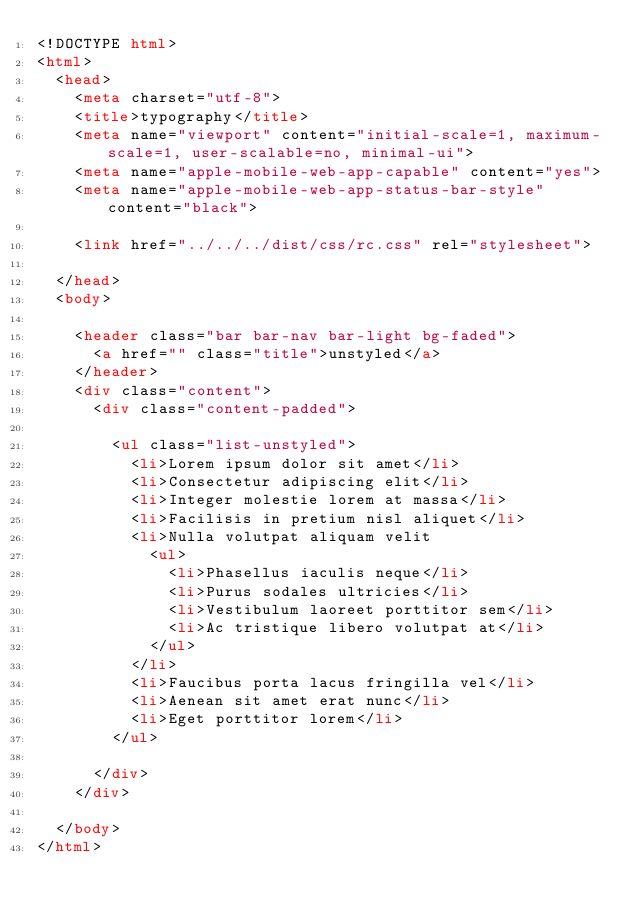<code> <loc_0><loc_0><loc_500><loc_500><_HTML_><!DOCTYPE html>
<html>
	<head>
		<meta charset="utf-8">
		<title>typography</title>
		<meta name="viewport" content="initial-scale=1, maximum-scale=1, user-scalable=no, minimal-ui">
		<meta name="apple-mobile-web-app-capable" content="yes">
		<meta name="apple-mobile-web-app-status-bar-style" content="black">

		<link href="../../../dist/css/rc.css" rel="stylesheet">

	</head>
	<body>

		<header class="bar bar-nav bar-light bg-faded">
		  <a href="" class="title">unstyled</a>
		</header>
		<div class="content">
			<div class="content-padded">

				<ul class="list-unstyled">
				  <li>Lorem ipsum dolor sit amet</li>
				  <li>Consectetur adipiscing elit</li>
				  <li>Integer molestie lorem at massa</li>
				  <li>Facilisis in pretium nisl aliquet</li>
				  <li>Nulla volutpat aliquam velit
				    <ul>
				      <li>Phasellus iaculis neque</li>
				      <li>Purus sodales ultricies</li>
				      <li>Vestibulum laoreet porttitor sem</li>
				      <li>Ac tristique libero volutpat at</li>
				    </ul>
				  </li>
				  <li>Faucibus porta lacus fringilla vel</li>
				  <li>Aenean sit amet erat nunc</li>
				  <li>Eget porttitor lorem</li>
				</ul>
				
			</div>
		</div>

	</body>
</html>
</code> 